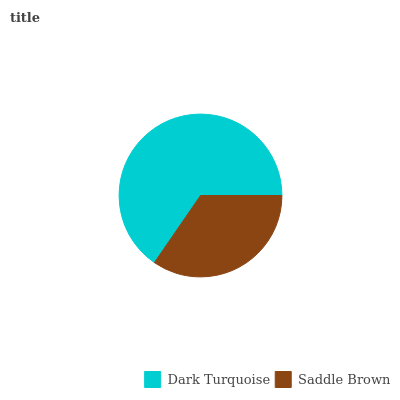Is Saddle Brown the minimum?
Answer yes or no. Yes. Is Dark Turquoise the maximum?
Answer yes or no. Yes. Is Saddle Brown the maximum?
Answer yes or no. No. Is Dark Turquoise greater than Saddle Brown?
Answer yes or no. Yes. Is Saddle Brown less than Dark Turquoise?
Answer yes or no. Yes. Is Saddle Brown greater than Dark Turquoise?
Answer yes or no. No. Is Dark Turquoise less than Saddle Brown?
Answer yes or no. No. Is Dark Turquoise the high median?
Answer yes or no. Yes. Is Saddle Brown the low median?
Answer yes or no. Yes. Is Saddle Brown the high median?
Answer yes or no. No. Is Dark Turquoise the low median?
Answer yes or no. No. 